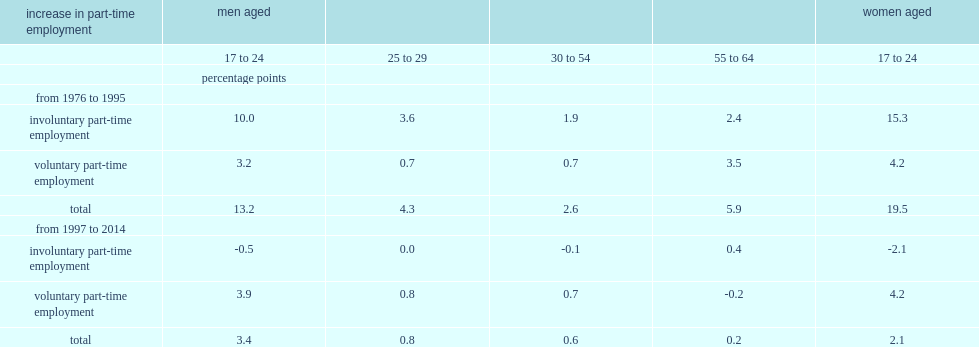Of the 13-percentage-point increase in part-time employment experienced by employed men aged 17 to 24 from 1976 to 1995, how many percent of the increase were due to higher involuntary part-time employment? 0.757576. How many percentage pointswere due to higher involuntary part-time employment, of 20 percentage points increase in part-time employment experience by employed women aged 17 to 24? 15.3. Would you be able to parse every entry in this table? {'header': ['increase in part-time employment', 'men aged', '', '', '', 'women aged'], 'rows': [['', '17 to 24', '25 to 29', '30 to 54', '55 to 64', '17 to 24'], ['', 'percentage points', '', '', '', ''], ['from 1976 to 1995', '', '', '', '', ''], ['involuntary part-time employment', '10.0', '3.6', '1.9', '2.4', '15.3'], ['voluntary part-time employment', '3.2', '0.7', '0.7', '3.5', '4.2'], ['total', '13.2', '4.3', '2.6', '5.9', '19.5'], ['from 1997 to 2014', '', '', '', '', ''], ['involuntary part-time employment', '-0.5', '0.0', '-0.1', '0.4', '-2.1'], ['voluntary part-time employment', '3.9', '0.8', '0.7', '-0.2', '4.2'], ['total', '3.4', '0.8', '0.6', '0.2', '2.1']]} 